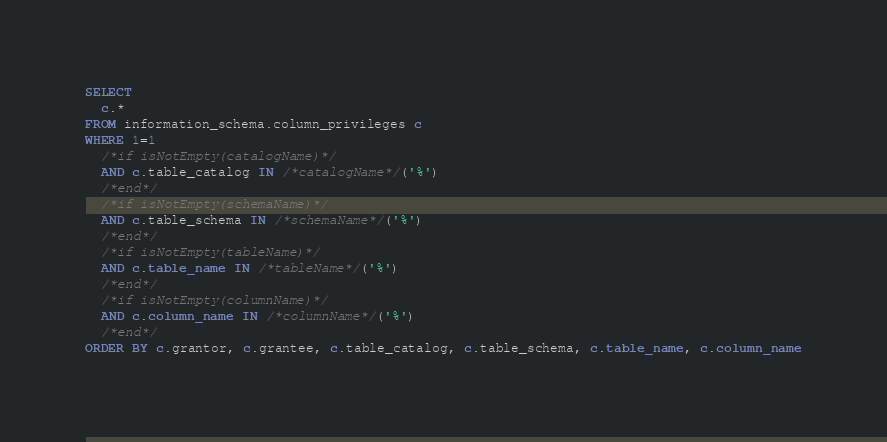<code> <loc_0><loc_0><loc_500><loc_500><_SQL_>SELECT
  c.*
FROM information_schema.column_privileges c
WHERE 1=1
  /*if isNotEmpty(catalogName)*/
  AND c.table_catalog IN /*catalogName*/('%')
  /*end*/
  /*if isNotEmpty(schemaName)*/
  AND c.table_schema IN /*schemaName*/('%')
  /*end*/
  /*if isNotEmpty(tableName)*/
  AND c.table_name IN /*tableName*/('%')
  /*end*/
  /*if isNotEmpty(columnName)*/
  AND c.column_name IN /*columnName*/('%')
  /*end*/
ORDER BY c.grantor, c.grantee, c.table_catalog, c.table_schema, c.table_name, c.column_name
</code> 